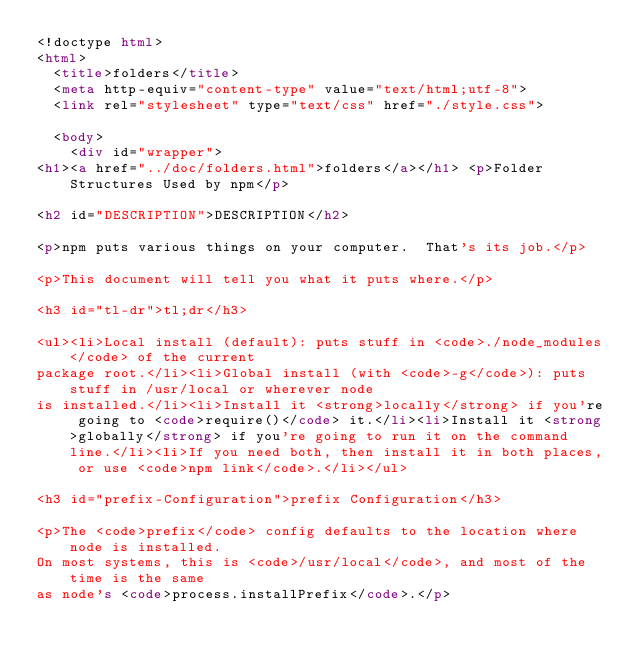Convert code to text. <code><loc_0><loc_0><loc_500><loc_500><_HTML_><!doctype html>
<html>
  <title>folders</title>
  <meta http-equiv="content-type" value="text/html;utf-8">
  <link rel="stylesheet" type="text/css" href="./style.css">

  <body>
    <div id="wrapper">
<h1><a href="../doc/folders.html">folders</a></h1> <p>Folder Structures Used by npm</p>

<h2 id="DESCRIPTION">DESCRIPTION</h2>

<p>npm puts various things on your computer.  That's its job.</p>

<p>This document will tell you what it puts where.</p>

<h3 id="tl-dr">tl;dr</h3>

<ul><li>Local install (default): puts stuff in <code>./node_modules</code> of the current
package root.</li><li>Global install (with <code>-g</code>): puts stuff in /usr/local or wherever node
is installed.</li><li>Install it <strong>locally</strong> if you're going to <code>require()</code> it.</li><li>Install it <strong>globally</strong> if you're going to run it on the command line.</li><li>If you need both, then install it in both places, or use <code>npm link</code>.</li></ul>

<h3 id="prefix-Configuration">prefix Configuration</h3>

<p>The <code>prefix</code> config defaults to the location where node is installed.
On most systems, this is <code>/usr/local</code>, and most of the time is the same
as node's <code>process.installPrefix</code>.</p>
</code> 